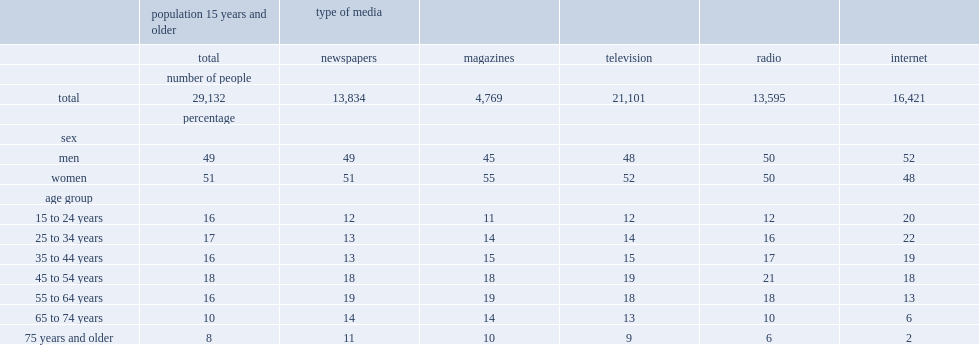In 2013,how many percentage point has seniors 65 years and older accounted for the population aged 15 and older? 18. How many of people read about news and current affairs in newspapers? 13834.0. How many percentage point of people who aged 65 and older read about news and current affairs in newspapers? 25. 